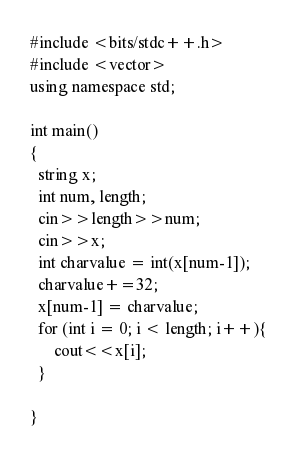Convert code to text. <code><loc_0><loc_0><loc_500><loc_500><_C++_>#include <bits/stdc++.h>
#include <vector>
using namespace std;

int main()
{
  string x;
  int num, length;
  cin>>length>>num;
  cin>>x;
  int charvalue = int(x[num-1]);
  charvalue+=32;
  x[num-1] = charvalue;
  for (int i = 0; i < length; i++){
      cout<<x[i];
  }
  
}</code> 